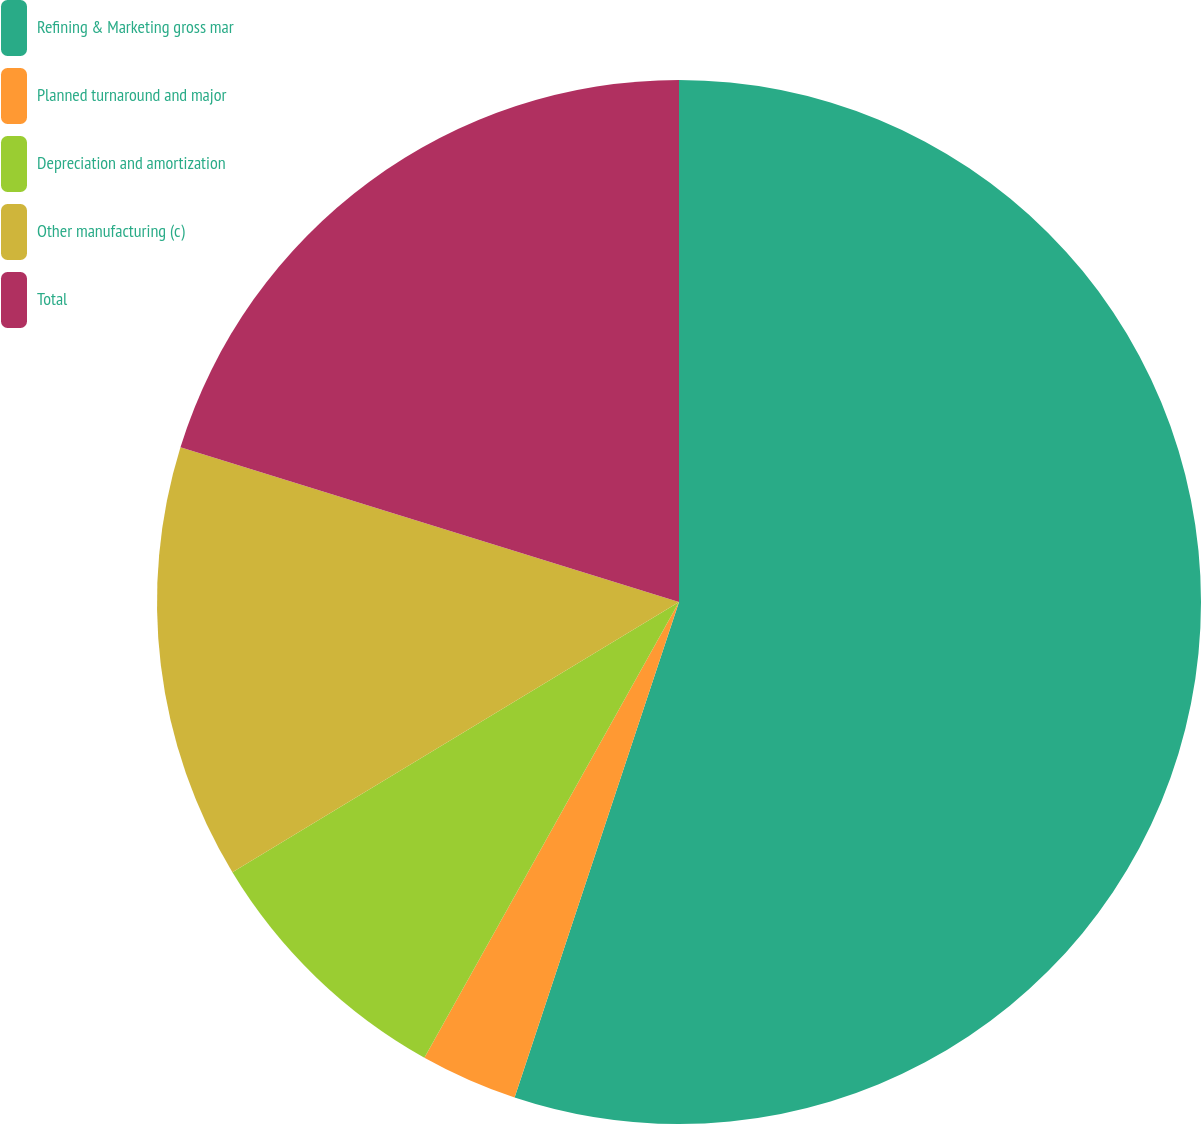Convert chart. <chart><loc_0><loc_0><loc_500><loc_500><pie_chart><fcel>Refining & Marketing gross mar<fcel>Planned turnaround and major<fcel>Depreciation and amortization<fcel>Other manufacturing (c)<fcel>Total<nl><fcel>55.1%<fcel>3.01%<fcel>8.23%<fcel>13.45%<fcel>20.21%<nl></chart> 